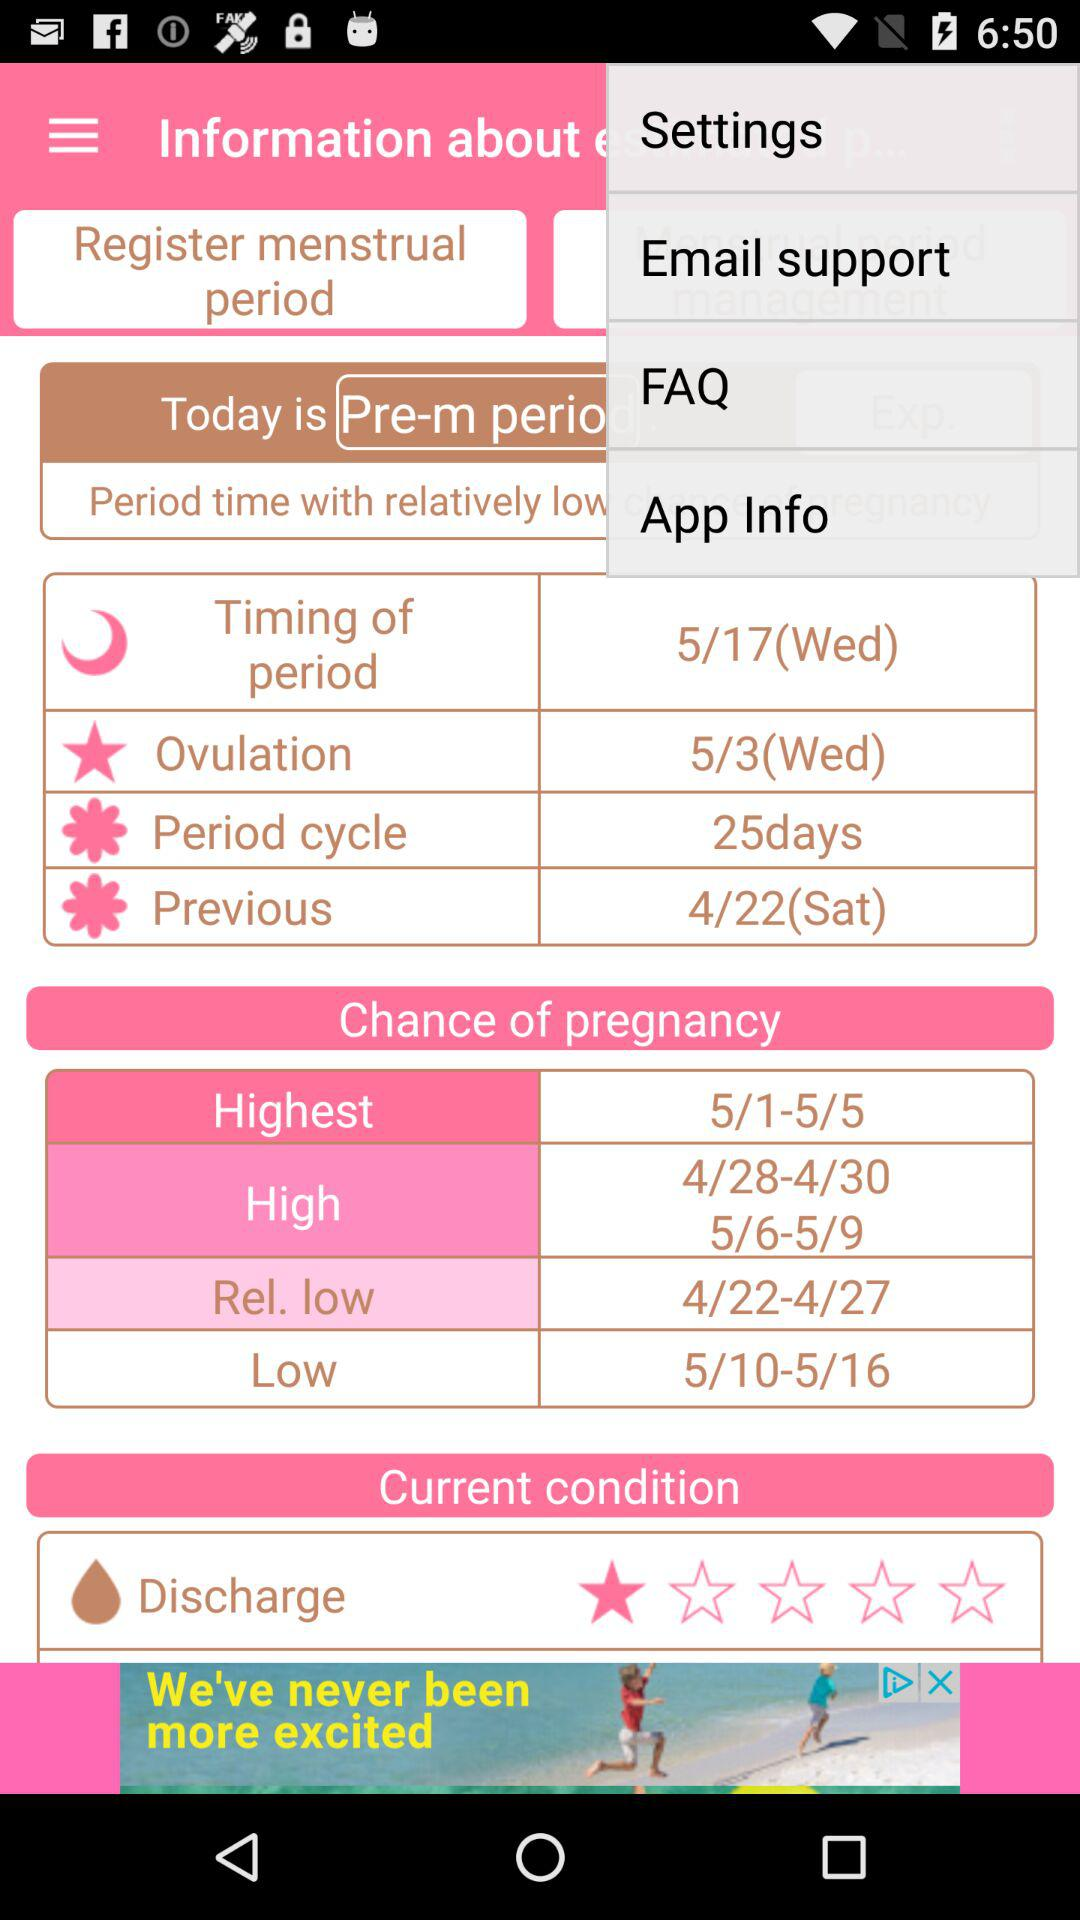When is there high chance of pregnancy? There is a high chance of pregnancy from April 28 to April 30 and May 6 to May 9. 